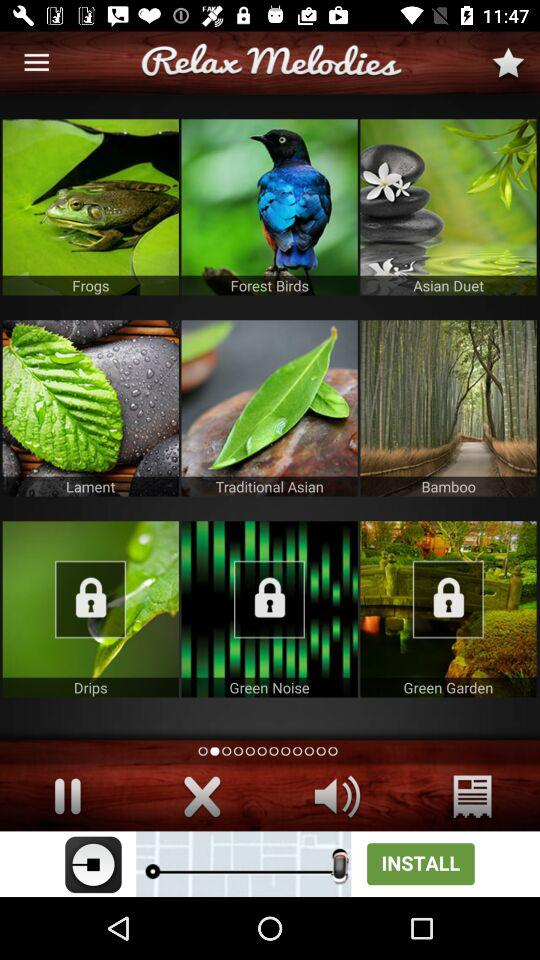What is the application name? The application name is "Relax Melodies". 